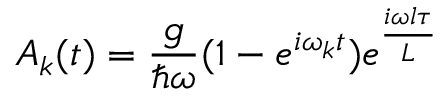Convert formula to latex. <formula><loc_0><loc_0><loc_500><loc_500>A _ { k } ( t ) = \frac { g } { \hbar { \omega } } ( 1 - e ^ { i \omega _ { k } t } ) e ^ { \frac { i \omega l \tau } { L } }</formula> 